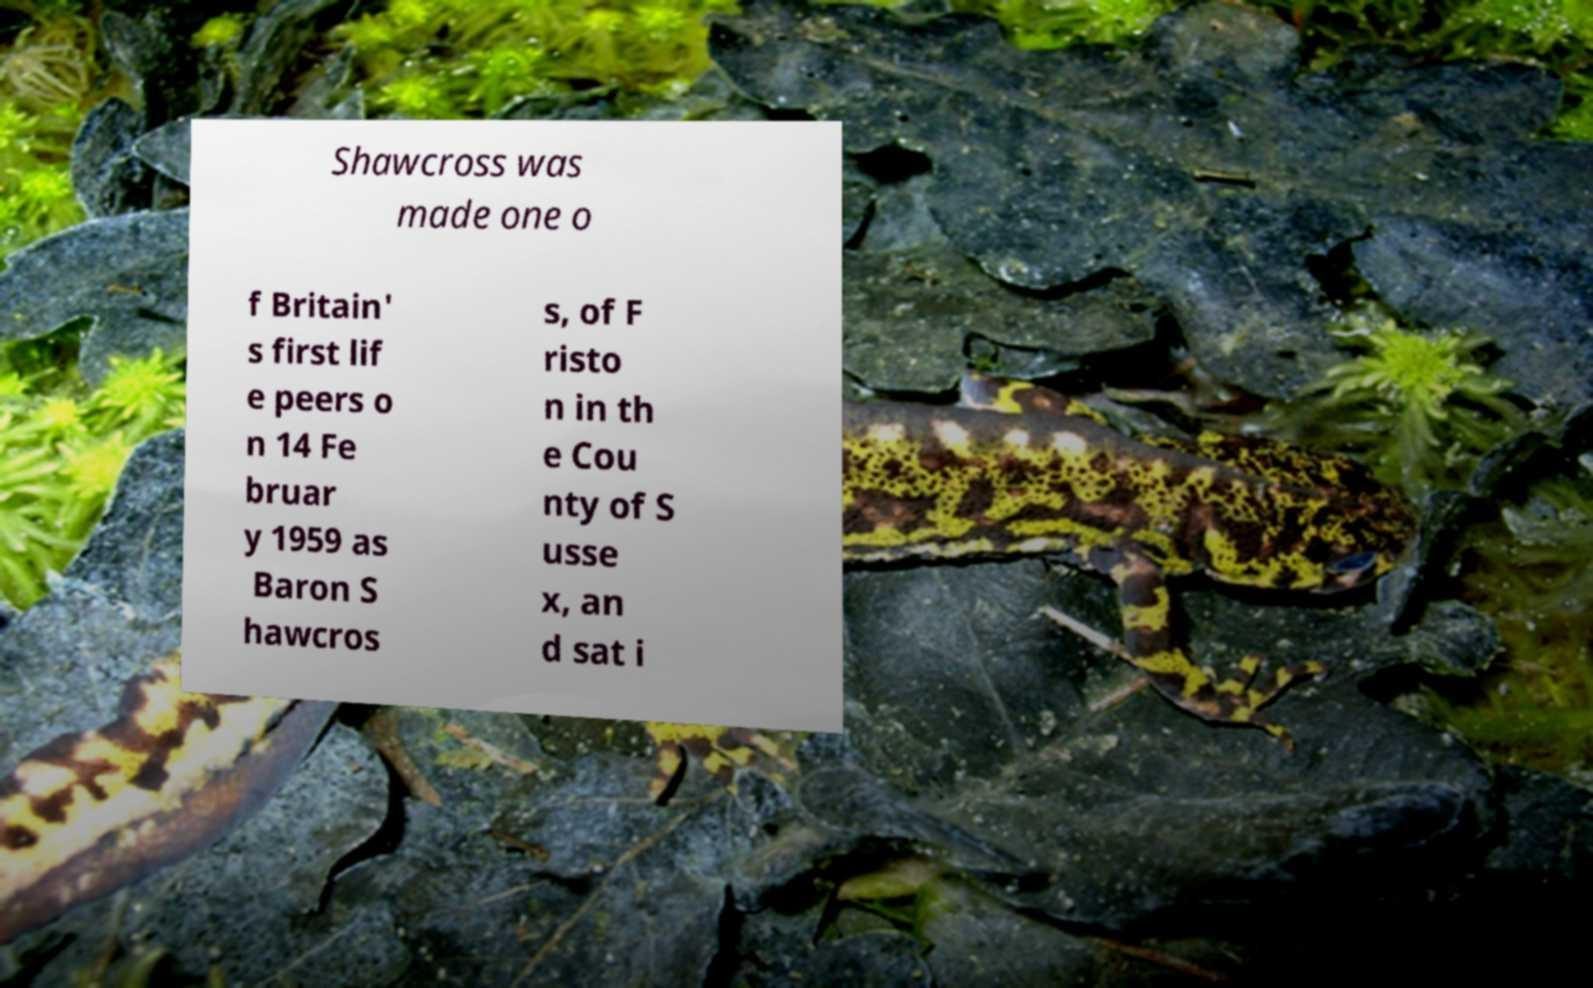For documentation purposes, I need the text within this image transcribed. Could you provide that? Shawcross was made one o f Britain' s first lif e peers o n 14 Fe bruar y 1959 as Baron S hawcros s, of F risto n in th e Cou nty of S usse x, an d sat i 